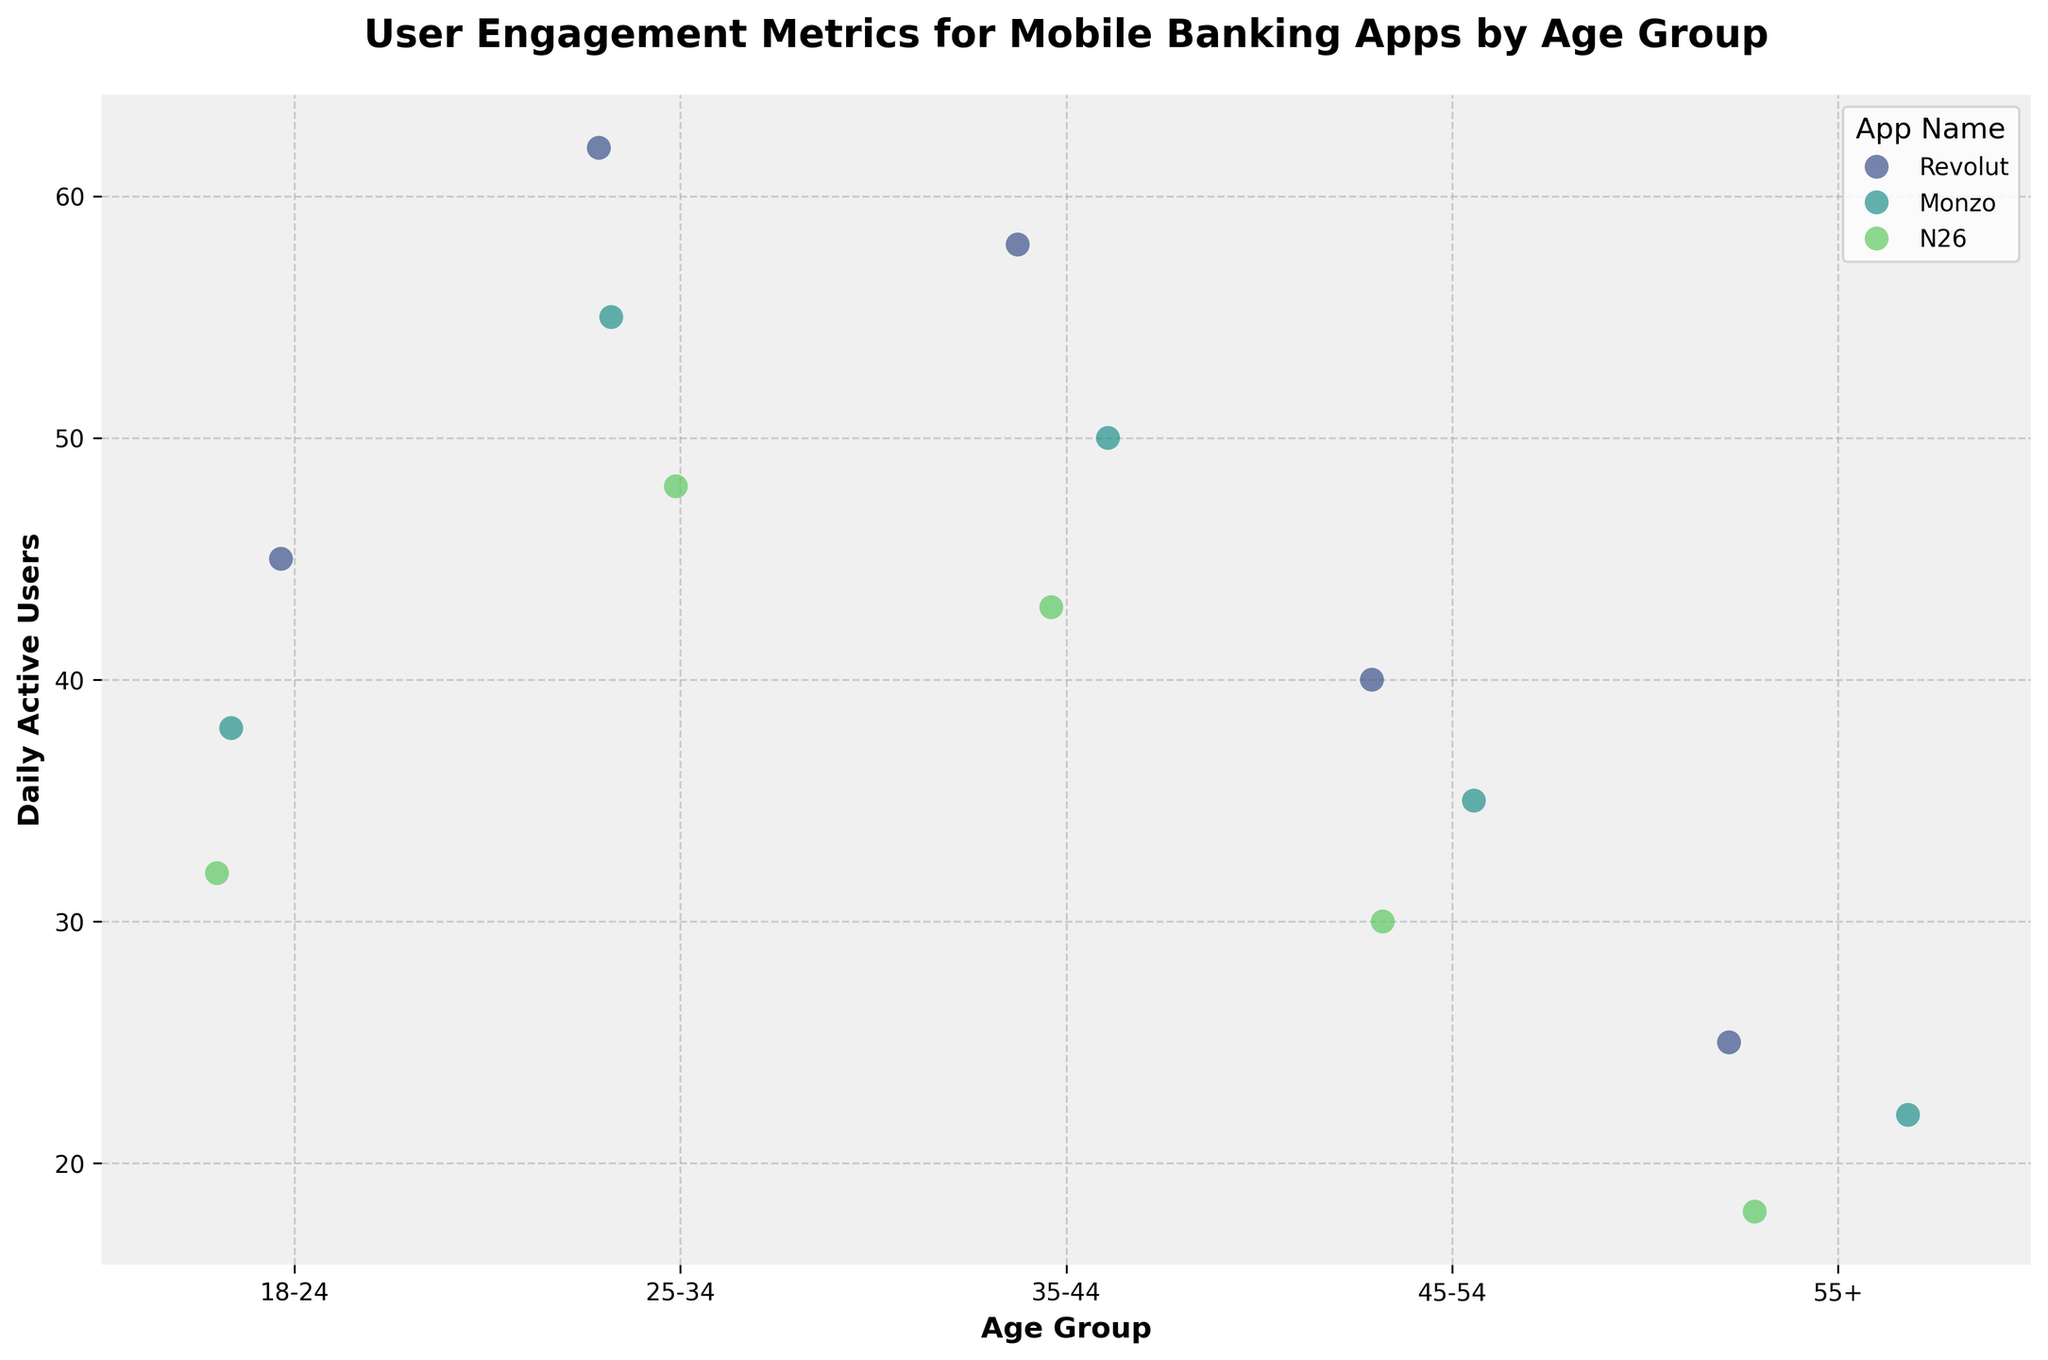What is the title of the plot? The title of the plot is written at the top and summarizes what the figure represents. The title is 'User Engagement Metrics for Mobile Banking Apps by Age Group'.
Answer: User Engagement Metrics for Mobile Banking Apps by Age Group What does the y-axis represent? The y-axis label is provided on the vertical line of the plot and it indicates what the values represent. Here, it is labeled 'Daily Active Users'.
Answer: Daily Active Users Which age group has the highest daily active users for Revolut? By looking at the highest point or value in the Revolut series within the strip plot, you can see that the 25-34 age group has the highest daily active users at 62.
Answer: 25-34 How do the daily active users for Monzo compare between the 25-34 and 55+ age groups? Comparing the heights of the points for Monzo in the 25-34 and 55+ age groups, the 25-34 group has 55 daily active users while the 55+ group has 22. So, 25-34 has more than twice as many active users as the 55+ age group.
Answer: 25-34 has more What is the range of daily active users for N26 across all age groups? The range is calculated by subtracting the minimum value from the maximum value for N26 points in the plot. The maximum is 48 (25-34), and the minimum is 18 (55+). So, the range is 48 - 18 = 30.
Answer: 30 Which app has the least daily active users in the 45-54 age group? By looking at the lowest value within the 45-54 age group section for each app, N26 has the least with 30 daily active users.
Answer: N26 What is the difference in daily active users between the 18-24 and 35-44 age groups for Monzo? Find and subtract the daily active users for Monzo in these two age groups: 38 (18-24) and 50 (35-44). The difference is 50 - 38 = 12.
Answer: 12 How does the distribution of users for Revolut compare across age groups? Observing the Revolut data points, the distribution shows 45 (18-24), 62 (25-34), 58 (35-44), 40 (45-54), and 25 (55+). Revolut has the highest activity in the 25-34 age group, and it generally decreases as the age increases beyond that.
Answer: Highest in 25-34, decreases with age Which app showed the greatest variability across age groups? To determine variability, observe the spread of points for each app. Revolut spans from 25 to 62 (a range of 37), Monzo spans from 22 to 55 (a range of 33), and N26 spans from 18 to 48 (a range of 30). So, Revolut has the greatest variability.
Answer: Revolut Is there an age group where all apps have similar user engagement? By examining the age groups, the 45-54 group shows values of 40, 35, and 30 for Revolut, Monzo, and N26 respectively, which are relatively close compared to other age groups.
Answer: 45-54 